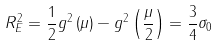Convert formula to latex. <formula><loc_0><loc_0><loc_500><loc_500>R _ { E } ^ { 2 } = \frac { 1 } { 2 } g ^ { 2 } \left ( \mu \right ) - g ^ { 2 } \left ( \frac { \mu } { 2 } \right ) = \frac { 3 } { 4 } \sigma _ { 0 }</formula> 